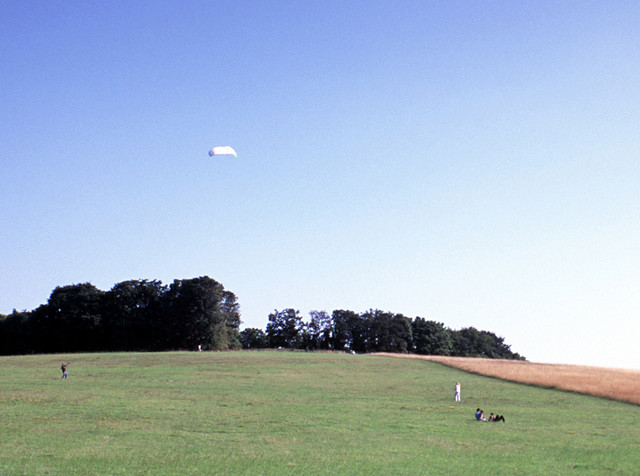Are there any signs of wildlife or nature in this image? Upon close examination, there aren't any immediately observable signs of wildlife in the image. However, the surrounding grassland and trees could potentially be home to a variety of small animals, birds, and insects. The natural setting and quiet atmosphere might also attract wildlife from nearby areas, though they are not evident in the picture. 